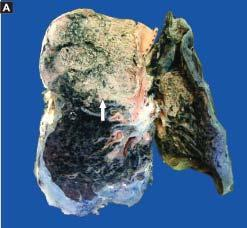what is the infiltrate in the lumina composed of?
Answer the question using a single word or phrase. Neutrophils and macrophages 